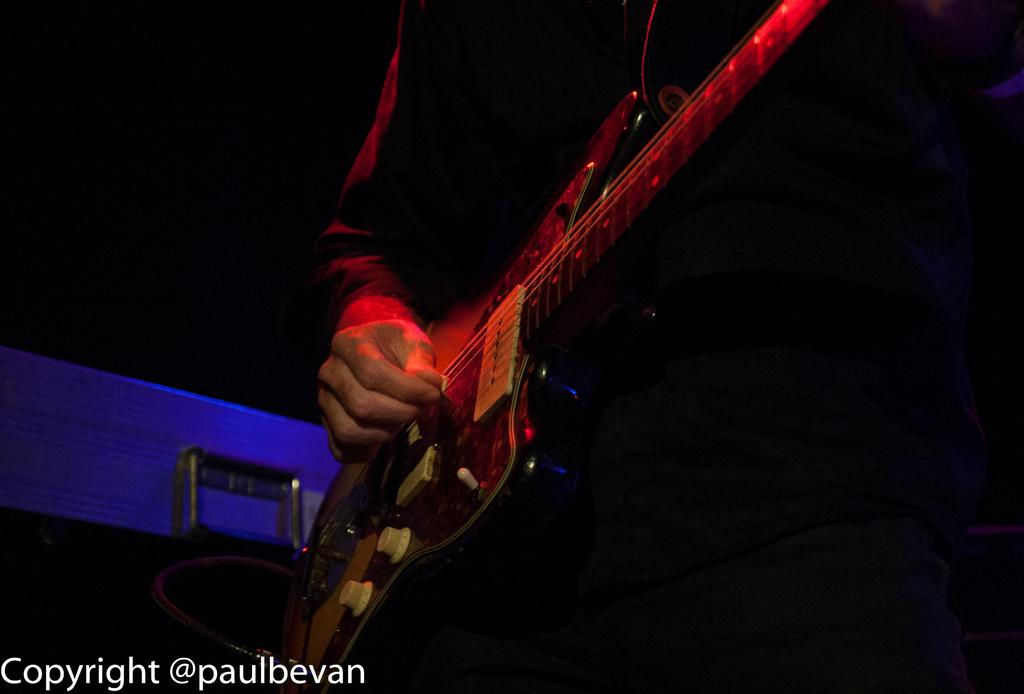What is the person's hand doing in the image? The person's hand is playing a guitar in the image. What object can be seen on the left side of the image? There is a chair on the left side of the image. How would you describe the lighting in the image? The background of the image is dark. Can you see a crown on the person's head in the image? No, there is no crown visible on the person's head in the image. Is there a cannon present in the image? No, there is no cannon present in the image. 